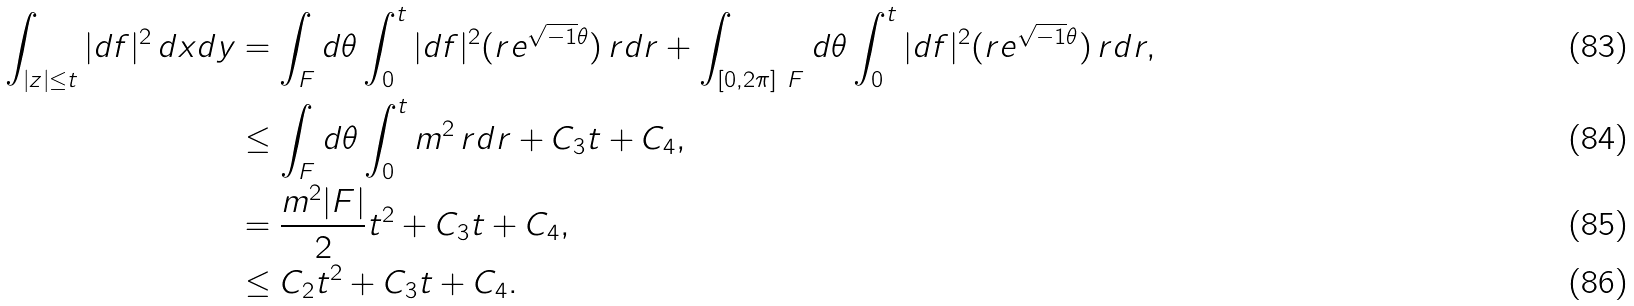<formula> <loc_0><loc_0><loc_500><loc_500>\int _ { | z | \leq t } | d f | ^ { 2 } \, d x d y & = \int _ { F } d \theta \int _ { 0 } ^ { t } | d f | ^ { 2 } ( r e ^ { \sqrt { - 1 } \theta } ) \, r d r + \int _ { [ 0 , 2 \pi ] \ F } d \theta \int _ { 0 } ^ { t } | d f | ^ { 2 } ( r e ^ { \sqrt { - 1 } \theta } ) \, r d r , \\ & \leq \int _ { F } d \theta \int _ { 0 } ^ { t } m ^ { 2 } \, r d r + C _ { 3 } t + C _ { 4 } , \\ & = \frac { m ^ { 2 } | F | } { 2 } t ^ { 2 } + C _ { 3 } t + C _ { 4 } , \\ & \leq C _ { 2 } t ^ { 2 } + C _ { 3 } t + C _ { 4 } .</formula> 